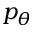Convert formula to latex. <formula><loc_0><loc_0><loc_500><loc_500>p _ { \theta }</formula> 